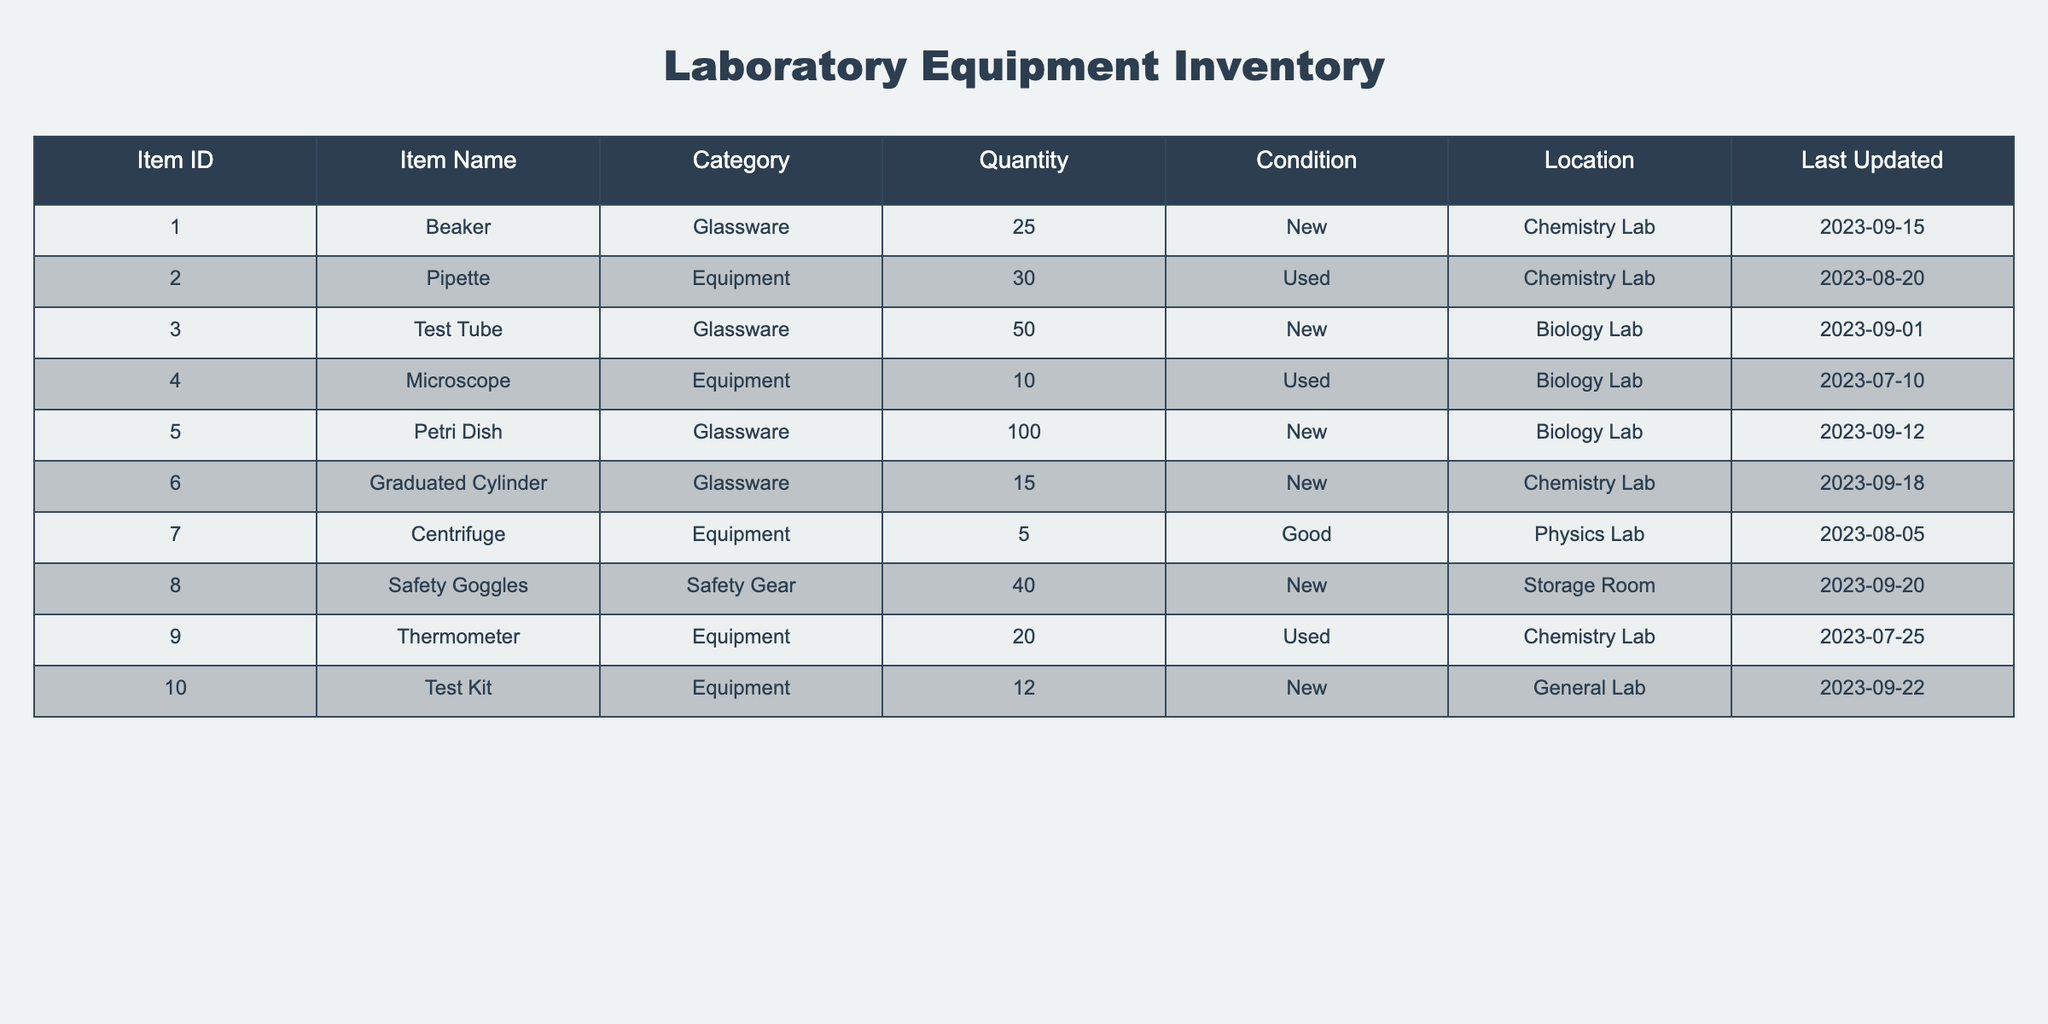What is the total quantity of glassware in the inventory? The table has three entries under the glassware category: Beaker (25), Test Tube (50), and Petri Dish (100). To find the total quantity, I sum these values: 25 + 50 + 100 = 175.
Answer: 175 How many pieces of equipment are in used condition? In the Equipment category, there are three items listed with the condition marked as used: Pipette (30), Microscope (10), and Thermometer (20). Therefore, the total quantity for used equipment is 30 + 10 + 20 = 60.
Answer: 60 Is there any safety gear located in the Chemistry Lab? The table lists Safety Goggles under the Safety Gear category, but it is not located in the Chemistry Lab; instead, it is stored in the Storage Room. Thus, the answer is no.
Answer: No What is the average quantity of equipment in the inventory? The Equipment category consists of 5 entries: Pipette (30), Microscope (10), Thermometer (20), Centrifuge (5), and Test Kit (12). First, I calculate the total quantity: 30 + 10 + 20 + 5 + 12 = 77. Then I divide by the number of entries (5) to find the average: 77 / 5 = 15.4.
Answer: 15.4 Which item has the largest quantity in the inventory? By examining the Quantity column, the largest entry is for Petri Dish, with a quantity of 100. Therefore, the item with the largest quantity is Petri Dish.
Answer: Petri Dish How many items are in good condition in the inventory? The table lists only one item in good condition: the Centrifuge (5). Therefore, the count of items in good condition is 1.
Answer: 1 What is the difference in quantity between the item with the highest and the lowest quantity? The item with the highest quantity is Petri Dish (100), and the item with the lowest is the Centrifuge (5). The difference is calculated as 100 - 5 = 95.
Answer: 95 Are there any items located in the Physics Lab? Yes, the table lists one item in the Physics Lab, which is the Centrifuge. Thus, the answer is yes.
Answer: Yes What percentage of the total inventory does the glassware represent? First, I calculate the total quantity across all items, which is 25 (Beaker) + 30 (Pipette) + 50 (Test Tube) + 10 (Microscope) + 100 (Petri Dish) + 15 (Graduated Cylinder) + 5 (Centrifuge) + 40 (Safety Goggles) + 20 (Thermometer) + 12 (Test Kit) = 327. The total quantity of glassware is 175. To find the percentage, I divide the glassware quantity by the total quantity and then multiply by 100: (175 / 327) * 100 ≈ 53.5%.
Answer: 53.5% 